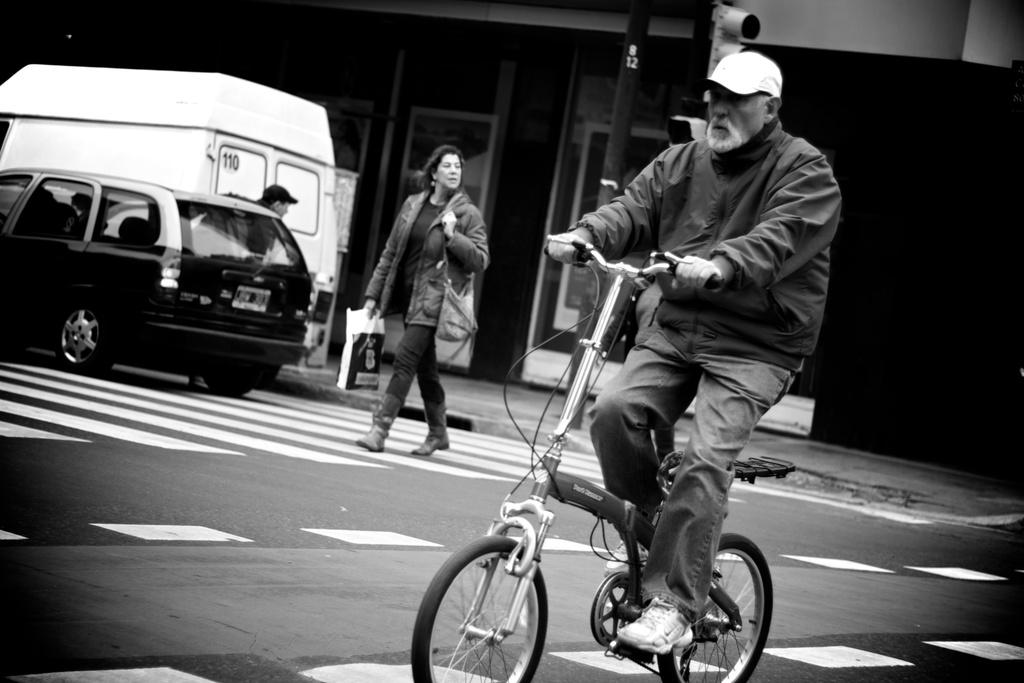What is the man in the image doing? The man is on a cycle in the image. What is the woman in the image doing? The woman is walking on the road. What vehicles can be seen in the background of the image? There is a van and a car in the background of the image. What else is present in the background of the image? There is a person and a traffic signal in the background of the image. What type of trousers is the library wearing in the image? There is no library present in the image, and therefore no trousers to describe. 